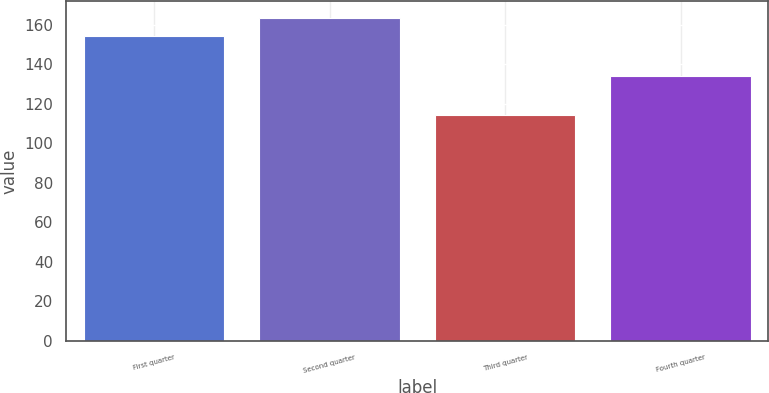Convert chart. <chart><loc_0><loc_0><loc_500><loc_500><bar_chart><fcel>First quarter<fcel>Second quarter<fcel>Third quarter<fcel>Fourth quarter<nl><fcel>154.33<fcel>163.57<fcel>114.53<fcel>134.17<nl></chart> 